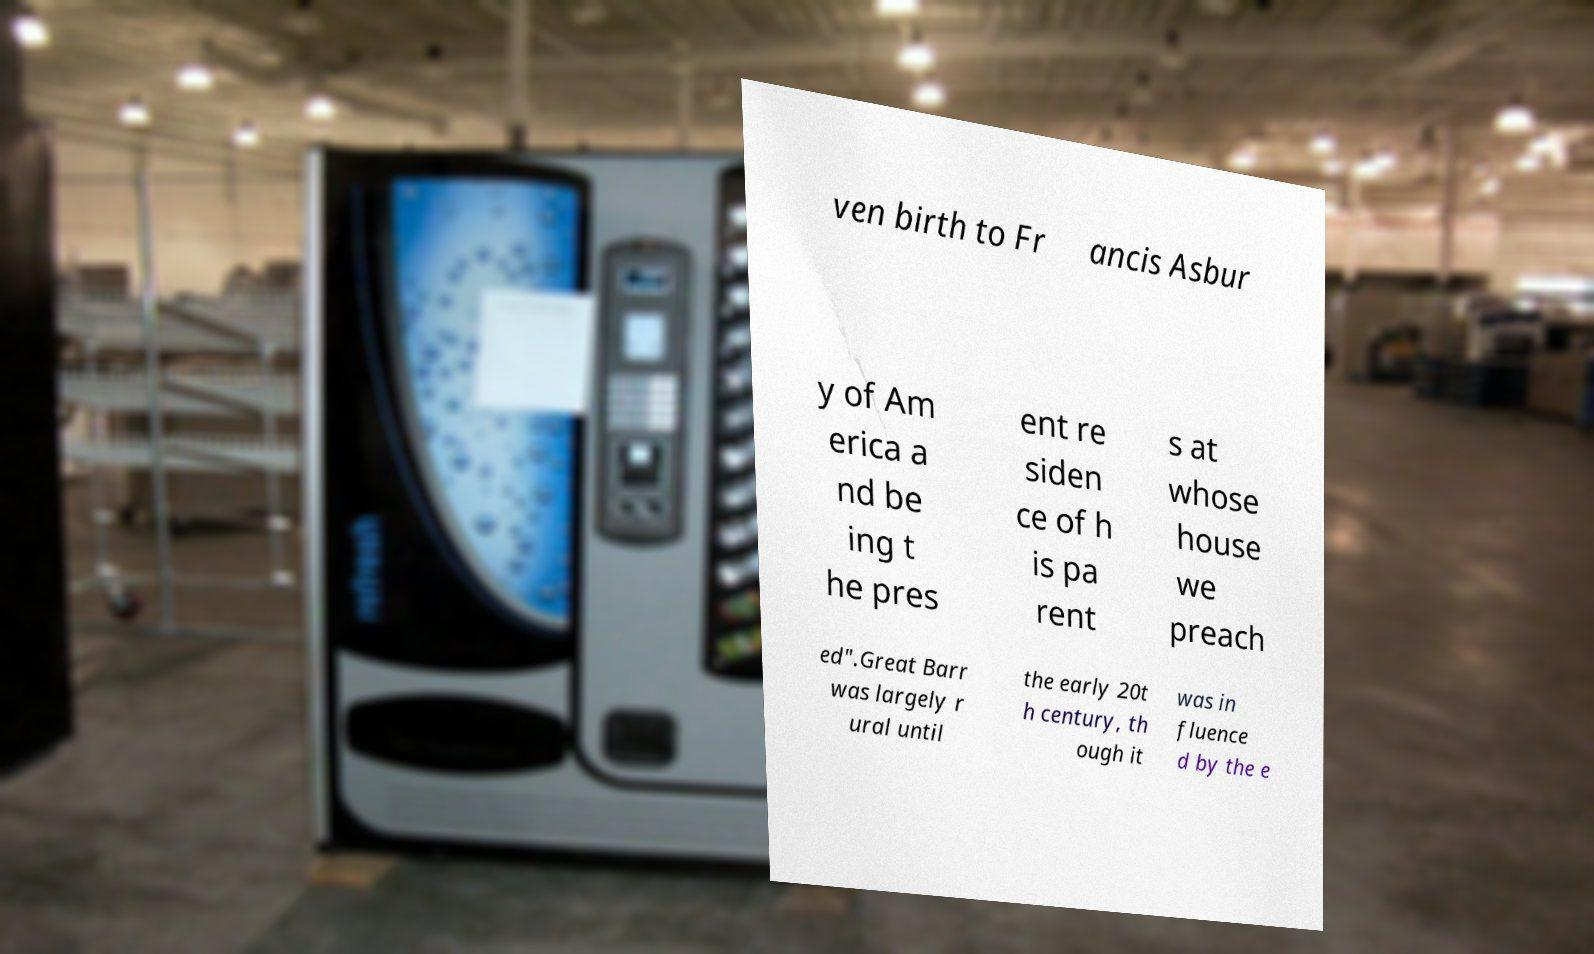For documentation purposes, I need the text within this image transcribed. Could you provide that? ven birth to Fr ancis Asbur y of Am erica a nd be ing t he pres ent re siden ce of h is pa rent s at whose house we preach ed".Great Barr was largely r ural until the early 20t h century, th ough it was in fluence d by the e 